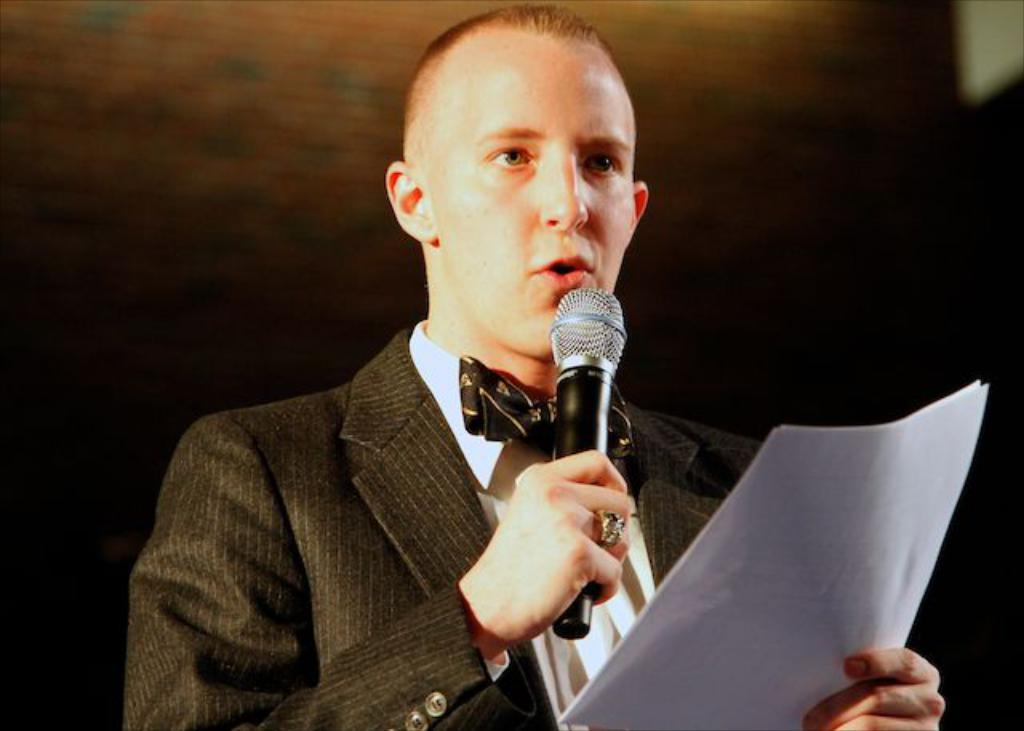What is the main subject of the image? There is a person in the center of the image. What is the person holding in the image? The person is holding a microphone and a paper. What might the person be doing with the microphone? The person might be talking, as they are holding a microphone. Are there any cobwebs visible in the image? There is no mention of cobwebs in the provided facts, so we cannot determine if any are present in the image. 